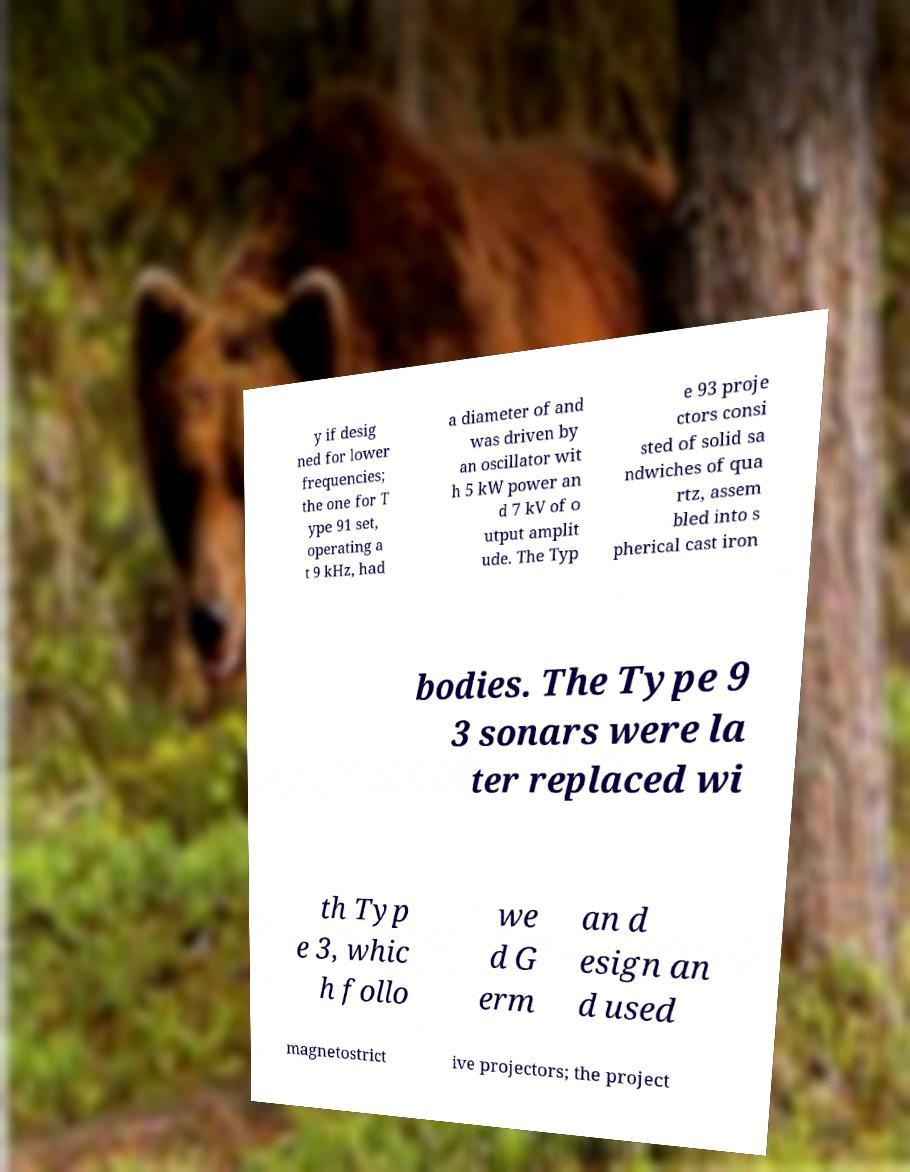There's text embedded in this image that I need extracted. Can you transcribe it verbatim? y if desig ned for lower frequencies; the one for T ype 91 set, operating a t 9 kHz, had a diameter of and was driven by an oscillator wit h 5 kW power an d 7 kV of o utput amplit ude. The Typ e 93 proje ctors consi sted of solid sa ndwiches of qua rtz, assem bled into s pherical cast iron bodies. The Type 9 3 sonars were la ter replaced wi th Typ e 3, whic h follo we d G erm an d esign an d used magnetostrict ive projectors; the project 